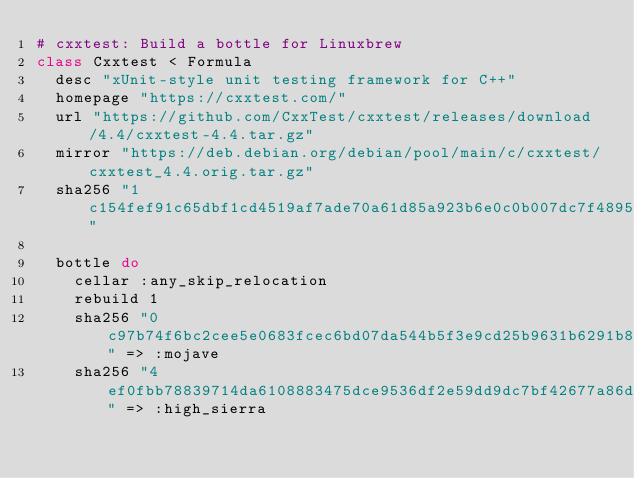Convert code to text. <code><loc_0><loc_0><loc_500><loc_500><_Ruby_># cxxtest: Build a bottle for Linuxbrew
class Cxxtest < Formula
  desc "xUnit-style unit testing framework for C++"
  homepage "https://cxxtest.com/"
  url "https://github.com/CxxTest/cxxtest/releases/download/4.4/cxxtest-4.4.tar.gz"
  mirror "https://deb.debian.org/debian/pool/main/c/cxxtest/cxxtest_4.4.orig.tar.gz"
  sha256 "1c154fef91c65dbf1cd4519af7ade70a61d85a923b6e0c0b007dc7f4895cf7d8"

  bottle do
    cellar :any_skip_relocation
    rebuild 1
    sha256 "0c97b74f6bc2cee5e0683fcec6bd07da544b5f3e9cd25b9631b6291b86490392" => :mojave
    sha256 "4ef0fbb78839714da6108883475dce9536df2e59dd9dc7bf42677a86d00f4356" => :high_sierra</code> 